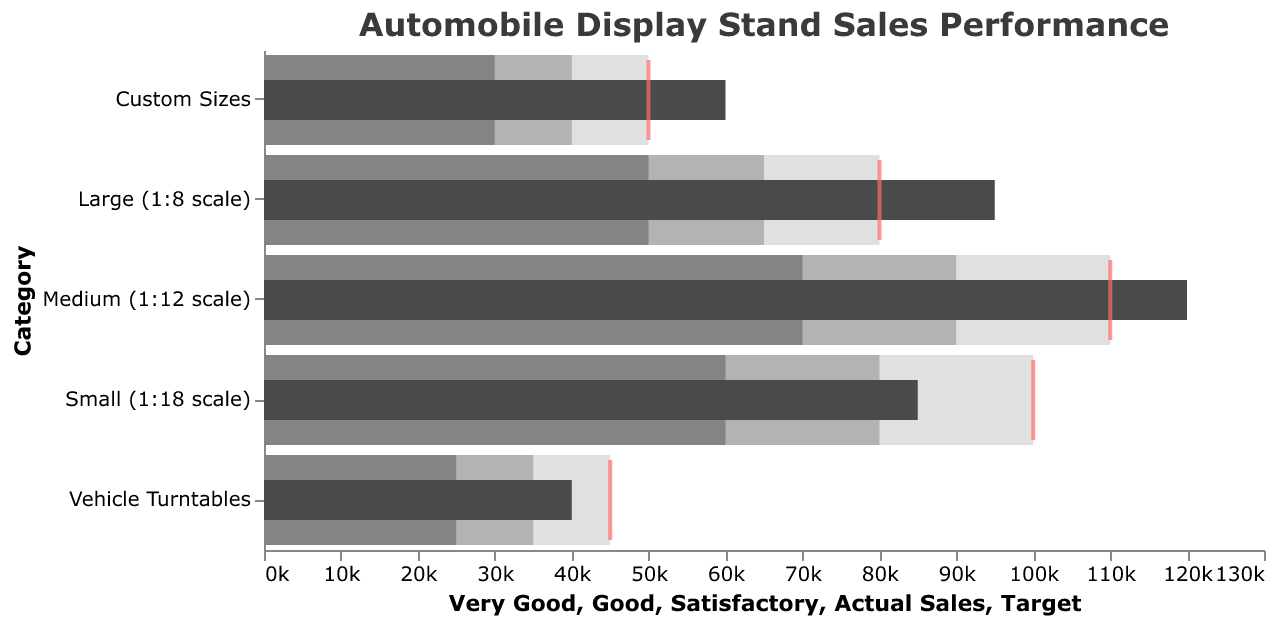Which category has the highest actual sales? By looking at the "Actual Sales" bars, the "Medium (1:12 scale)" category has the longest bar, indicating the highest actual sales.
Answer: Medium (1:12 scale) Which category's actual sales surpassed its target by the largest amount? Compare the length of the "Actual Sales" bars to the position of the red ticks (targets). "Medium (1:12 scale)" has the largest difference between its actual sales bar (120,000) and its target tick (110,000), indicating it surpassed its target by the largest amount (10,000).
Answer: Medium (1:12 scale) What is the target sales value for "Vehicle Turntables"? The red tick for "Vehicle Turntables" is positioned at 45,000, which represents the target sales value for this category.
Answer: 45,000 Which category performed below satisfactory according to the bullet chart? The "Vehicle Turntables" category's actual sales bar (40,000) is below its "Satisfactory" threshold (35,000), indicating it performed below satisfactory.
Answer: Vehicle Turntables How much more did "Large (1:8 scale)" sell compared to its satisfactory threshold? The actual sales for "Large (1:8 scale)" is 95,000. The satisfactory threshold is 50,000. Subtracting these gives 95,000 - 50,000 = 45,000 more.
Answer: 45,000 What is the range for the satisfactory sales level in the "Medium (1:12 scale)" category? The satisfactory sales range is defined between the "Poor" threshold and the "Satisfactory" threshold. For "Medium (1:12 scale)," these are 0 and 70,000, respectively. Thus, the range is from 0 to 70,000.
Answer: 0 to 70,000 Which size category has both its actual sales and target sales in the "Very Good" range? By observing the shading and actual sales bars, "Small (1:18 scale)" has both actual sales (85,000) and target sales (100,000) in the "Very Good" range.
Answer: Small (1:18 scale) How many categories have actual sales exceeding their respective targets? Compare the position of "Actual Sales" bars with the targets (red ticks). Three categories ("Medium (1:12 scale)", "Large (1:8 scale)", and "Custom Sizes") have bars extending beyond their target ticks.
Answer: Three What is the total actual sales for "Custom Sizes" and "Vehicle Turntables"? Adding the actual sales of "Custom Sizes" (60,000) and "Vehicle Turntables" (40,000) gives a total of 60,000 + 40,000 = 100,000.
Answer: 100,000 